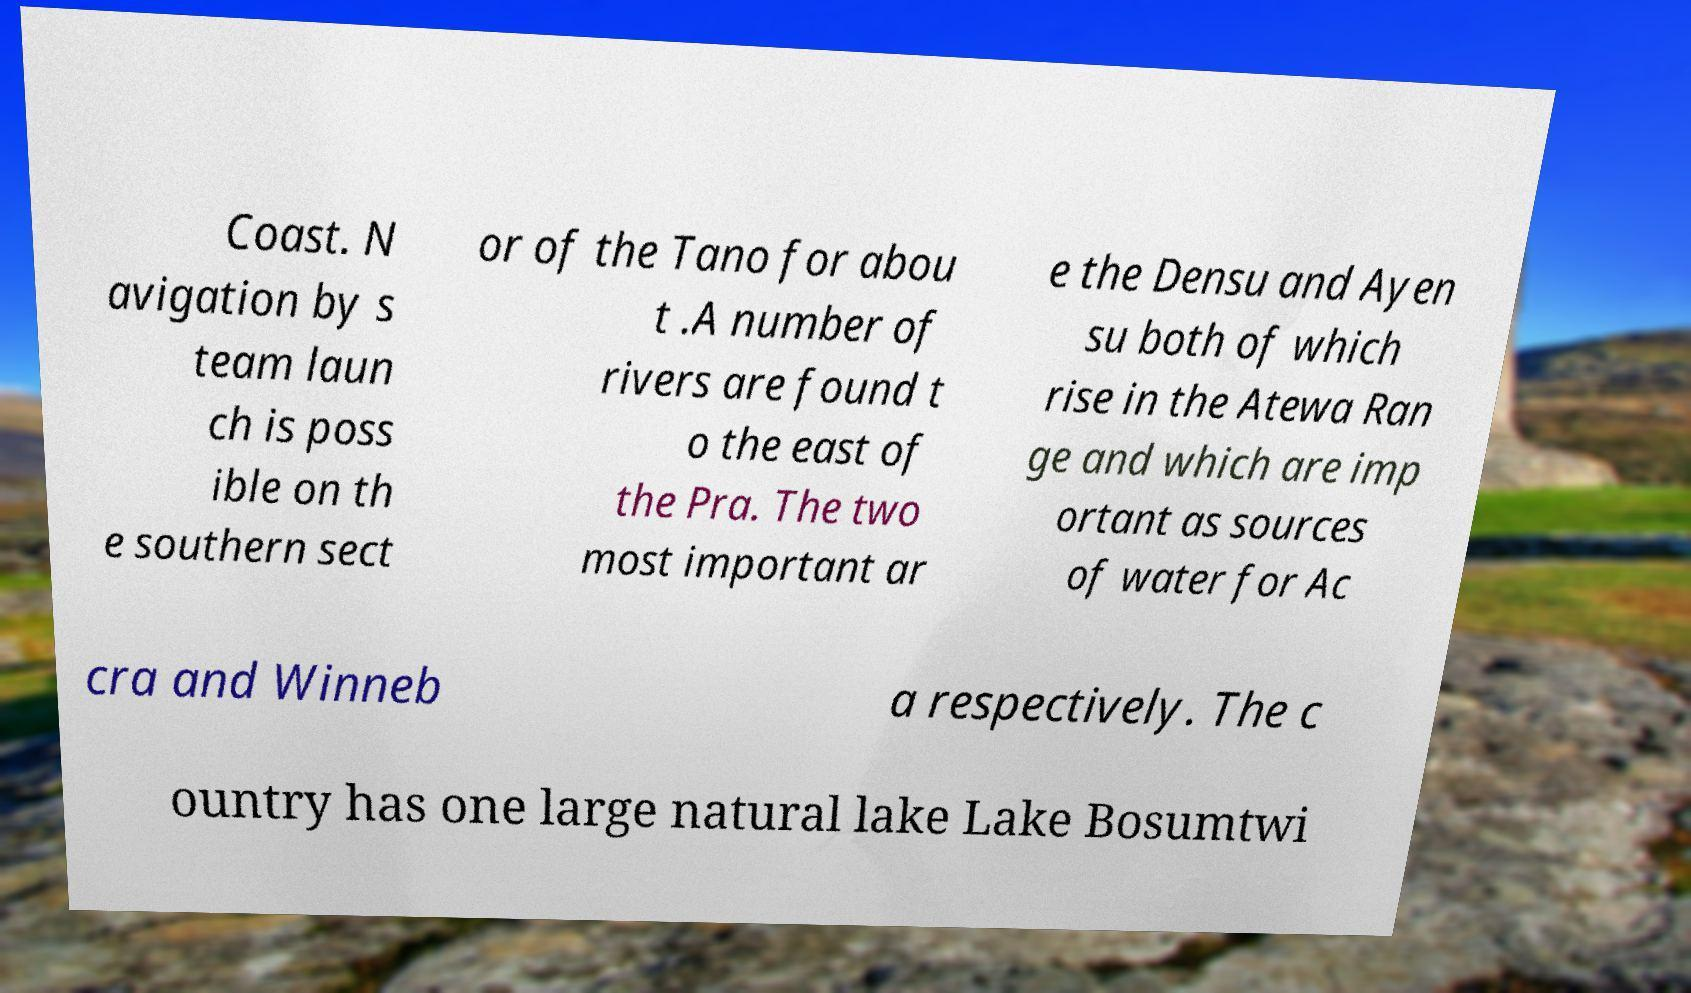I need the written content from this picture converted into text. Can you do that? Coast. N avigation by s team laun ch is poss ible on th e southern sect or of the Tano for abou t .A number of rivers are found t o the east of the Pra. The two most important ar e the Densu and Ayen su both of which rise in the Atewa Ran ge and which are imp ortant as sources of water for Ac cra and Winneb a respectively. The c ountry has one large natural lake Lake Bosumtwi 